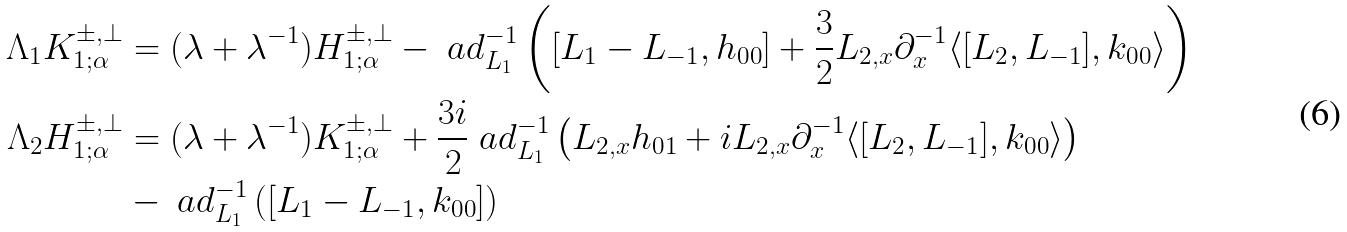Convert formula to latex. <formula><loc_0><loc_0><loc_500><loc_500>\Lambda _ { 1 } K _ { 1 ; \alpha } ^ { \pm , \perp } & = ( \lambda + \lambda ^ { - 1 } ) H _ { 1 ; \alpha } ^ { \pm , \perp } - \ a d _ { L _ { 1 } } ^ { - 1 } \left ( [ L _ { 1 } - L _ { - 1 } , h _ { 0 0 } ] + \frac { 3 } { 2 } L _ { 2 , x } \partial _ { x } ^ { - 1 } \langle [ L _ { 2 } , L _ { - 1 } ] , k _ { 0 0 } \rangle \right ) \\ \Lambda _ { 2 } H _ { 1 ; \alpha } ^ { \pm , \perp } & = ( \lambda + \lambda ^ { - 1 } ) K _ { 1 ; \alpha } ^ { \pm , \perp } + \frac { 3 i } { 2 } \ a d _ { L _ { 1 } } ^ { - 1 } \left ( L _ { 2 , x } h _ { 0 1 } + i L _ { 2 , x } \partial _ { x } ^ { - 1 } \langle [ L _ { 2 } , L _ { - 1 } ] , k _ { 0 0 } \rangle \right ) \\ & - \ a d _ { L _ { 1 } } ^ { - 1 } \left ( [ L _ { 1 } - L _ { - 1 } , k _ { 0 0 } ] \right )</formula> 